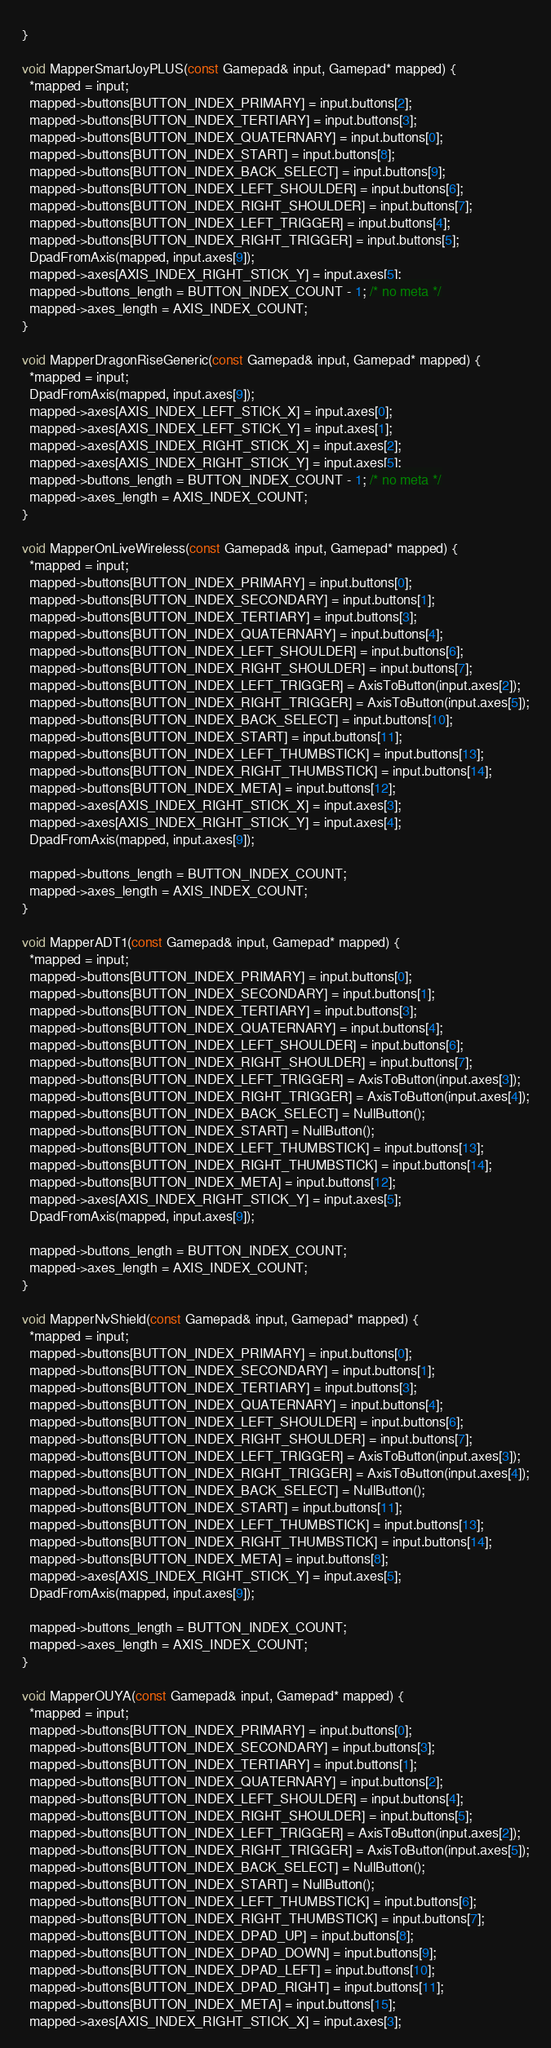<code> <loc_0><loc_0><loc_500><loc_500><_ObjectiveC_>}

void MapperSmartJoyPLUS(const Gamepad& input, Gamepad* mapped) {
  *mapped = input;
  mapped->buttons[BUTTON_INDEX_PRIMARY] = input.buttons[2];
  mapped->buttons[BUTTON_INDEX_TERTIARY] = input.buttons[3];
  mapped->buttons[BUTTON_INDEX_QUATERNARY] = input.buttons[0];
  mapped->buttons[BUTTON_INDEX_START] = input.buttons[8];
  mapped->buttons[BUTTON_INDEX_BACK_SELECT] = input.buttons[9];
  mapped->buttons[BUTTON_INDEX_LEFT_SHOULDER] = input.buttons[6];
  mapped->buttons[BUTTON_INDEX_RIGHT_SHOULDER] = input.buttons[7];
  mapped->buttons[BUTTON_INDEX_LEFT_TRIGGER] = input.buttons[4];
  mapped->buttons[BUTTON_INDEX_RIGHT_TRIGGER] = input.buttons[5];
  DpadFromAxis(mapped, input.axes[9]);
  mapped->axes[AXIS_INDEX_RIGHT_STICK_Y] = input.axes[5];
  mapped->buttons_length = BUTTON_INDEX_COUNT - 1; /* no meta */
  mapped->axes_length = AXIS_INDEX_COUNT;
}

void MapperDragonRiseGeneric(const Gamepad& input, Gamepad* mapped) {
  *mapped = input;
  DpadFromAxis(mapped, input.axes[9]);
  mapped->axes[AXIS_INDEX_LEFT_STICK_X] = input.axes[0];
  mapped->axes[AXIS_INDEX_LEFT_STICK_Y] = input.axes[1];
  mapped->axes[AXIS_INDEX_RIGHT_STICK_X] = input.axes[2];
  mapped->axes[AXIS_INDEX_RIGHT_STICK_Y] = input.axes[5];
  mapped->buttons_length = BUTTON_INDEX_COUNT - 1; /* no meta */
  mapped->axes_length = AXIS_INDEX_COUNT;
}

void MapperOnLiveWireless(const Gamepad& input, Gamepad* mapped) {
  *mapped = input;
  mapped->buttons[BUTTON_INDEX_PRIMARY] = input.buttons[0];
  mapped->buttons[BUTTON_INDEX_SECONDARY] = input.buttons[1];
  mapped->buttons[BUTTON_INDEX_TERTIARY] = input.buttons[3];
  mapped->buttons[BUTTON_INDEX_QUATERNARY] = input.buttons[4];
  mapped->buttons[BUTTON_INDEX_LEFT_SHOULDER] = input.buttons[6];
  mapped->buttons[BUTTON_INDEX_RIGHT_SHOULDER] = input.buttons[7];
  mapped->buttons[BUTTON_INDEX_LEFT_TRIGGER] = AxisToButton(input.axes[2]);
  mapped->buttons[BUTTON_INDEX_RIGHT_TRIGGER] = AxisToButton(input.axes[5]);
  mapped->buttons[BUTTON_INDEX_BACK_SELECT] = input.buttons[10];
  mapped->buttons[BUTTON_INDEX_START] = input.buttons[11];
  mapped->buttons[BUTTON_INDEX_LEFT_THUMBSTICK] = input.buttons[13];
  mapped->buttons[BUTTON_INDEX_RIGHT_THUMBSTICK] = input.buttons[14];
  mapped->buttons[BUTTON_INDEX_META] = input.buttons[12];
  mapped->axes[AXIS_INDEX_RIGHT_STICK_X] = input.axes[3];
  mapped->axes[AXIS_INDEX_RIGHT_STICK_Y] = input.axes[4];
  DpadFromAxis(mapped, input.axes[9]);

  mapped->buttons_length = BUTTON_INDEX_COUNT;
  mapped->axes_length = AXIS_INDEX_COUNT;
}

void MapperADT1(const Gamepad& input, Gamepad* mapped) {
  *mapped = input;
  mapped->buttons[BUTTON_INDEX_PRIMARY] = input.buttons[0];
  mapped->buttons[BUTTON_INDEX_SECONDARY] = input.buttons[1];
  mapped->buttons[BUTTON_INDEX_TERTIARY] = input.buttons[3];
  mapped->buttons[BUTTON_INDEX_QUATERNARY] = input.buttons[4];
  mapped->buttons[BUTTON_INDEX_LEFT_SHOULDER] = input.buttons[6];
  mapped->buttons[BUTTON_INDEX_RIGHT_SHOULDER] = input.buttons[7];
  mapped->buttons[BUTTON_INDEX_LEFT_TRIGGER] = AxisToButton(input.axes[3]);
  mapped->buttons[BUTTON_INDEX_RIGHT_TRIGGER] = AxisToButton(input.axes[4]);
  mapped->buttons[BUTTON_INDEX_BACK_SELECT] = NullButton();
  mapped->buttons[BUTTON_INDEX_START] = NullButton();
  mapped->buttons[BUTTON_INDEX_LEFT_THUMBSTICK] = input.buttons[13];
  mapped->buttons[BUTTON_INDEX_RIGHT_THUMBSTICK] = input.buttons[14];
  mapped->buttons[BUTTON_INDEX_META] = input.buttons[12];
  mapped->axes[AXIS_INDEX_RIGHT_STICK_Y] = input.axes[5];
  DpadFromAxis(mapped, input.axes[9]);

  mapped->buttons_length = BUTTON_INDEX_COUNT;
  mapped->axes_length = AXIS_INDEX_COUNT;
}

void MapperNvShield(const Gamepad& input, Gamepad* mapped) {
  *mapped = input;
  mapped->buttons[BUTTON_INDEX_PRIMARY] = input.buttons[0];
  mapped->buttons[BUTTON_INDEX_SECONDARY] = input.buttons[1];
  mapped->buttons[BUTTON_INDEX_TERTIARY] = input.buttons[3];
  mapped->buttons[BUTTON_INDEX_QUATERNARY] = input.buttons[4];
  mapped->buttons[BUTTON_INDEX_LEFT_SHOULDER] = input.buttons[6];
  mapped->buttons[BUTTON_INDEX_RIGHT_SHOULDER] = input.buttons[7];
  mapped->buttons[BUTTON_INDEX_LEFT_TRIGGER] = AxisToButton(input.axes[3]);
  mapped->buttons[BUTTON_INDEX_RIGHT_TRIGGER] = AxisToButton(input.axes[4]);
  mapped->buttons[BUTTON_INDEX_BACK_SELECT] = NullButton();
  mapped->buttons[BUTTON_INDEX_START] = input.buttons[11];
  mapped->buttons[BUTTON_INDEX_LEFT_THUMBSTICK] = input.buttons[13];
  mapped->buttons[BUTTON_INDEX_RIGHT_THUMBSTICK] = input.buttons[14];
  mapped->buttons[BUTTON_INDEX_META] = input.buttons[8];
  mapped->axes[AXIS_INDEX_RIGHT_STICK_Y] = input.axes[5];
  DpadFromAxis(mapped, input.axes[9]);

  mapped->buttons_length = BUTTON_INDEX_COUNT;
  mapped->axes_length = AXIS_INDEX_COUNT;
}

void MapperOUYA(const Gamepad& input, Gamepad* mapped) {
  *mapped = input;
  mapped->buttons[BUTTON_INDEX_PRIMARY] = input.buttons[0];
  mapped->buttons[BUTTON_INDEX_SECONDARY] = input.buttons[3];
  mapped->buttons[BUTTON_INDEX_TERTIARY] = input.buttons[1];
  mapped->buttons[BUTTON_INDEX_QUATERNARY] = input.buttons[2];
  mapped->buttons[BUTTON_INDEX_LEFT_SHOULDER] = input.buttons[4];
  mapped->buttons[BUTTON_INDEX_RIGHT_SHOULDER] = input.buttons[5];
  mapped->buttons[BUTTON_INDEX_LEFT_TRIGGER] = AxisToButton(input.axes[2]);
  mapped->buttons[BUTTON_INDEX_RIGHT_TRIGGER] = AxisToButton(input.axes[5]);
  mapped->buttons[BUTTON_INDEX_BACK_SELECT] = NullButton();
  mapped->buttons[BUTTON_INDEX_START] = NullButton();
  mapped->buttons[BUTTON_INDEX_LEFT_THUMBSTICK] = input.buttons[6];
  mapped->buttons[BUTTON_INDEX_RIGHT_THUMBSTICK] = input.buttons[7];
  mapped->buttons[BUTTON_INDEX_DPAD_UP] = input.buttons[8];
  mapped->buttons[BUTTON_INDEX_DPAD_DOWN] = input.buttons[9];
  mapped->buttons[BUTTON_INDEX_DPAD_LEFT] = input.buttons[10];
  mapped->buttons[BUTTON_INDEX_DPAD_RIGHT] = input.buttons[11];
  mapped->buttons[BUTTON_INDEX_META] = input.buttons[15];
  mapped->axes[AXIS_INDEX_RIGHT_STICK_X] = input.axes[3];</code> 